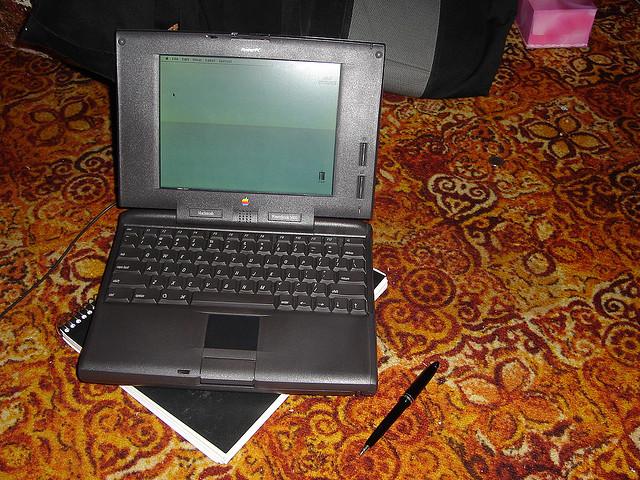What is under the laptop?
Quick response, please. Notebook. What color is the carpet?
Concise answer only. Orange. Is the laptop big or small?
Keep it brief. Small. 